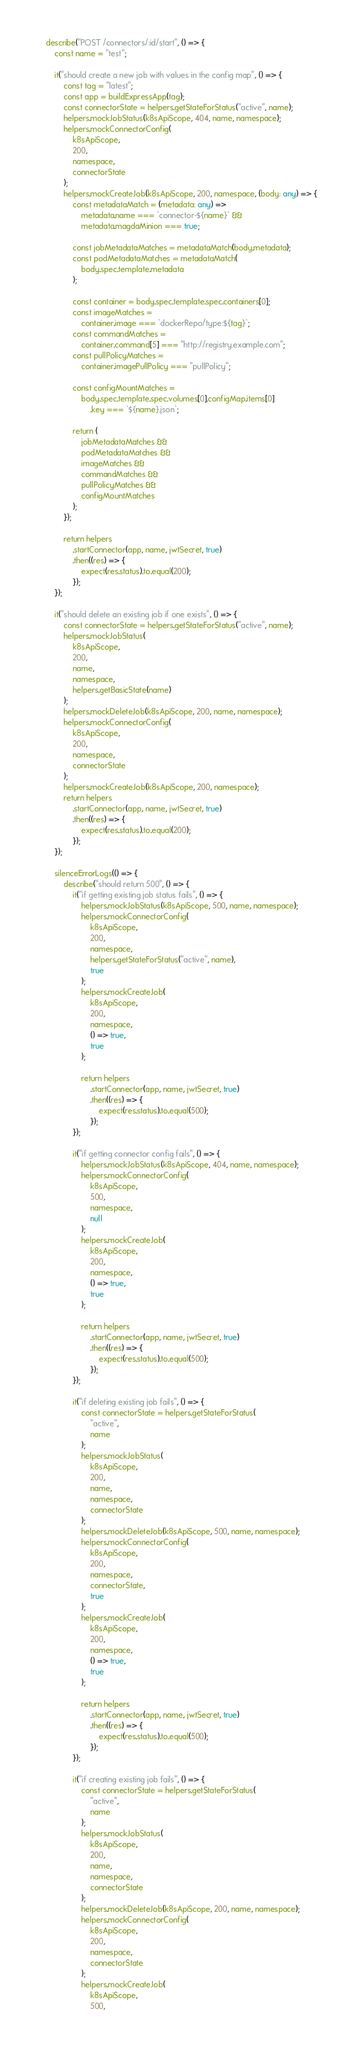Convert code to text. <code><loc_0><loc_0><loc_500><loc_500><_TypeScript_>
    describe("POST /connectors/:id/start", () => {
        const name = "test";

        it("should create a new job with values in the config map", () => {
            const tag = "latest";
            const app = buildExpressApp(tag);
            const connectorState = helpers.getStateForStatus("active", name);
            helpers.mockJobStatus(k8sApiScope, 404, name, namespace);
            helpers.mockConnectorConfig(
                k8sApiScope,
                200,
                namespace,
                connectorState
            );
            helpers.mockCreateJob(k8sApiScope, 200, namespace, (body: any) => {
                const metadataMatch = (metadata: any) =>
                    metadata.name === `connector-${name}` &&
                    metadata.magdaMinion === true;

                const jobMetadataMatches = metadataMatch(body.metadata);
                const podMetadataMatches = metadataMatch(
                    body.spec.template.metadata
                );

                const container = body.spec.template.spec.containers[0];
                const imageMatches =
                    container.image === `dockerRepo/type:${tag}`;
                const commandMatches =
                    container.command[5] === "http://registry.example.com";
                const pullPolicyMatches =
                    container.imagePullPolicy === "pullPolicy";

                const configMountMatches =
                    body.spec.template.spec.volumes[0].configMap.items[0]
                        .key === `${name}.json`;

                return (
                    jobMetadataMatches &&
                    podMetadataMatches &&
                    imageMatches &&
                    commandMatches &&
                    pullPolicyMatches &&
                    configMountMatches
                );
            });

            return helpers
                .startConnector(app, name, jwtSecret, true)
                .then((res) => {
                    expect(res.status).to.equal(200);
                });
        });

        it("should delete an existing job if one exists", () => {
            const connectorState = helpers.getStateForStatus("active", name);
            helpers.mockJobStatus(
                k8sApiScope,
                200,
                name,
                namespace,
                helpers.getBasicState(name)
            );
            helpers.mockDeleteJob(k8sApiScope, 200, name, namespace);
            helpers.mockConnectorConfig(
                k8sApiScope,
                200,
                namespace,
                connectorState
            );
            helpers.mockCreateJob(k8sApiScope, 200, namespace);
            return helpers
                .startConnector(app, name, jwtSecret, true)
                .then((res) => {
                    expect(res.status).to.equal(200);
                });
        });

        silenceErrorLogs(() => {
            describe("should return 500", () => {
                it("if getting existing job status fails", () => {
                    helpers.mockJobStatus(k8sApiScope, 500, name, namespace);
                    helpers.mockConnectorConfig(
                        k8sApiScope,
                        200,
                        namespace,
                        helpers.getStateForStatus("active", name),
                        true
                    );
                    helpers.mockCreateJob(
                        k8sApiScope,
                        200,
                        namespace,
                        () => true,
                        true
                    );

                    return helpers
                        .startConnector(app, name, jwtSecret, true)
                        .then((res) => {
                            expect(res.status).to.equal(500);
                        });
                });

                it("if getting connector config fails", () => {
                    helpers.mockJobStatus(k8sApiScope, 404, name, namespace);
                    helpers.mockConnectorConfig(
                        k8sApiScope,
                        500,
                        namespace,
                        null
                    );
                    helpers.mockCreateJob(
                        k8sApiScope,
                        200,
                        namespace,
                        () => true,
                        true
                    );

                    return helpers
                        .startConnector(app, name, jwtSecret, true)
                        .then((res) => {
                            expect(res.status).to.equal(500);
                        });
                });

                it("if deleting existing job fails", () => {
                    const connectorState = helpers.getStateForStatus(
                        "active",
                        name
                    );
                    helpers.mockJobStatus(
                        k8sApiScope,
                        200,
                        name,
                        namespace,
                        connectorState
                    );
                    helpers.mockDeleteJob(k8sApiScope, 500, name, namespace);
                    helpers.mockConnectorConfig(
                        k8sApiScope,
                        200,
                        namespace,
                        connectorState,
                        true
                    );
                    helpers.mockCreateJob(
                        k8sApiScope,
                        200,
                        namespace,
                        () => true,
                        true
                    );

                    return helpers
                        .startConnector(app, name, jwtSecret, true)
                        .then((res) => {
                            expect(res.status).to.equal(500);
                        });
                });

                it("if creating existing job fails", () => {
                    const connectorState = helpers.getStateForStatus(
                        "active",
                        name
                    );
                    helpers.mockJobStatus(
                        k8sApiScope,
                        200,
                        name,
                        namespace,
                        connectorState
                    );
                    helpers.mockDeleteJob(k8sApiScope, 200, name, namespace);
                    helpers.mockConnectorConfig(
                        k8sApiScope,
                        200,
                        namespace,
                        connectorState
                    );
                    helpers.mockCreateJob(
                        k8sApiScope,
                        500,</code> 